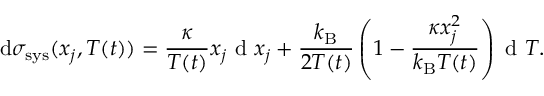<formula> <loc_0><loc_0><loc_500><loc_500>d \sigma _ { s y s } ( x _ { j } , T ( t ) ) = \frac { \kappa } { T ( t ) } x _ { j } d x _ { j } + \frac { k _ { B } } { 2 T ( t ) } \left ( 1 - \frac { \kappa x _ { j } ^ { 2 } } { k _ { B } T ( t ) } \right ) d T .</formula> 